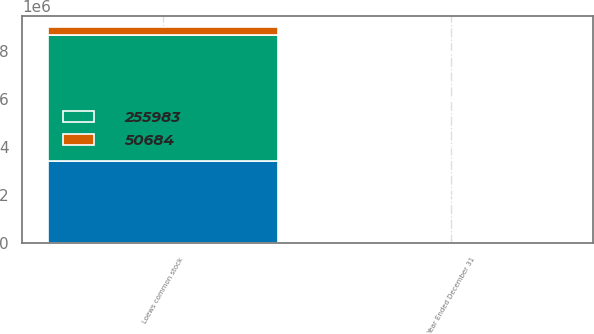Convert chart to OTSL. <chart><loc_0><loc_0><loc_500><loc_500><stacked_bar_chart><ecel><fcel>Year Ended December 31<fcel>Loews common stock<nl><fcel>nan<fcel>2009<fcel>3.43578e+06<nl><fcel>255983<fcel>2008<fcel>5.25201e+06<nl><fcel>50684<fcel>2007<fcel>352583<nl></chart> 